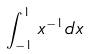<formula> <loc_0><loc_0><loc_500><loc_500>\int _ { - 1 } ^ { 1 } x ^ { - 1 } d x</formula> 